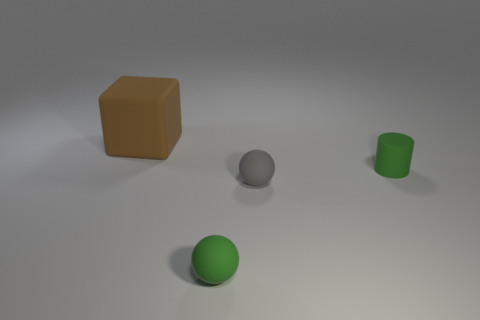Add 4 gray objects. How many objects exist? 8 Subtract all gray spheres. How many spheres are left? 1 Subtract 1 blocks. How many blocks are left? 0 Add 2 spheres. How many spheres are left? 4 Add 2 big shiny things. How many big shiny things exist? 2 Subtract 0 red cylinders. How many objects are left? 4 Subtract all cylinders. How many objects are left? 3 Subtract all purple balls. Subtract all cyan cylinders. How many balls are left? 2 Subtract all large blue matte things. Subtract all green cylinders. How many objects are left? 3 